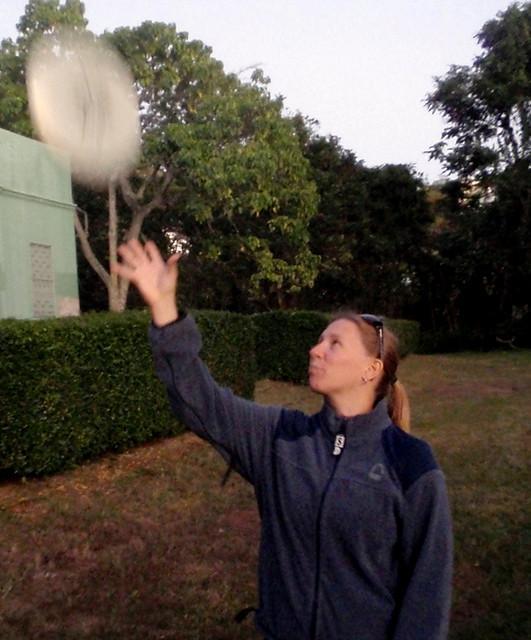How many slices of sandwich are there?
Give a very brief answer. 0. 